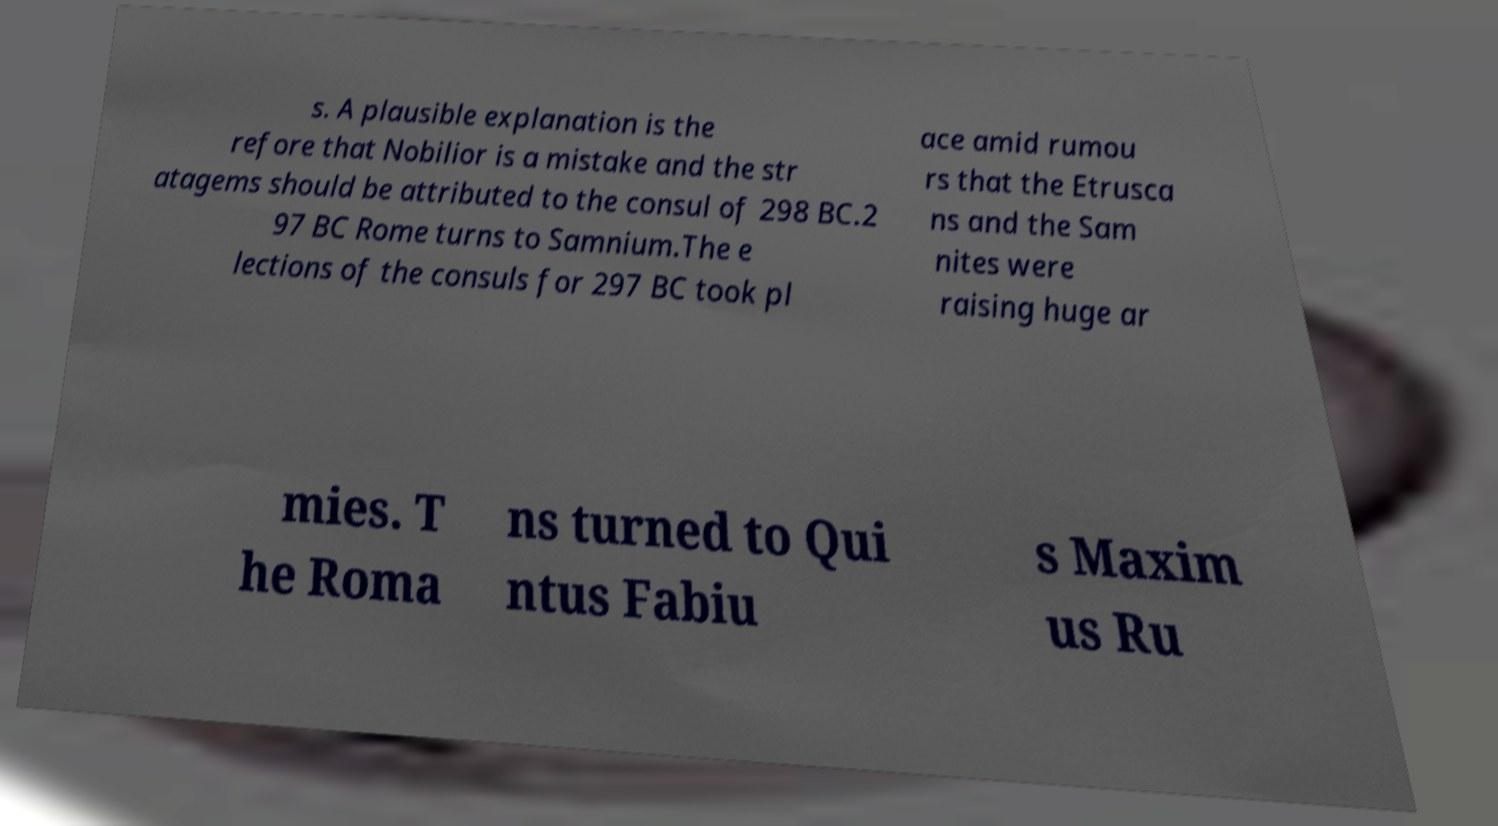There's text embedded in this image that I need extracted. Can you transcribe it verbatim? s. A plausible explanation is the refore that Nobilior is a mistake and the str atagems should be attributed to the consul of 298 BC.2 97 BC Rome turns to Samnium.The e lections of the consuls for 297 BC took pl ace amid rumou rs that the Etrusca ns and the Sam nites were raising huge ar mies. T he Roma ns turned to Qui ntus Fabiu s Maxim us Ru 